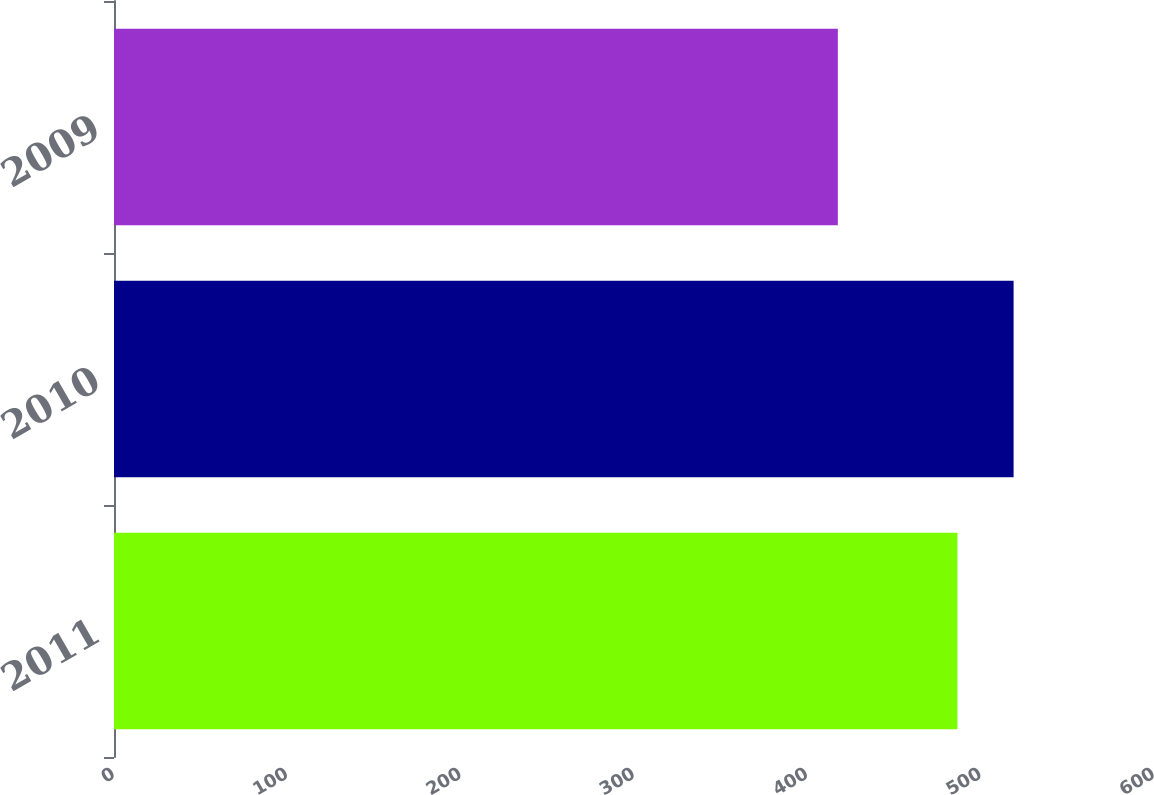Convert chart. <chart><loc_0><loc_0><loc_500><loc_500><bar_chart><fcel>2011<fcel>2010<fcel>2009<nl><fcel>486.6<fcel>519<fcel>417.6<nl></chart> 